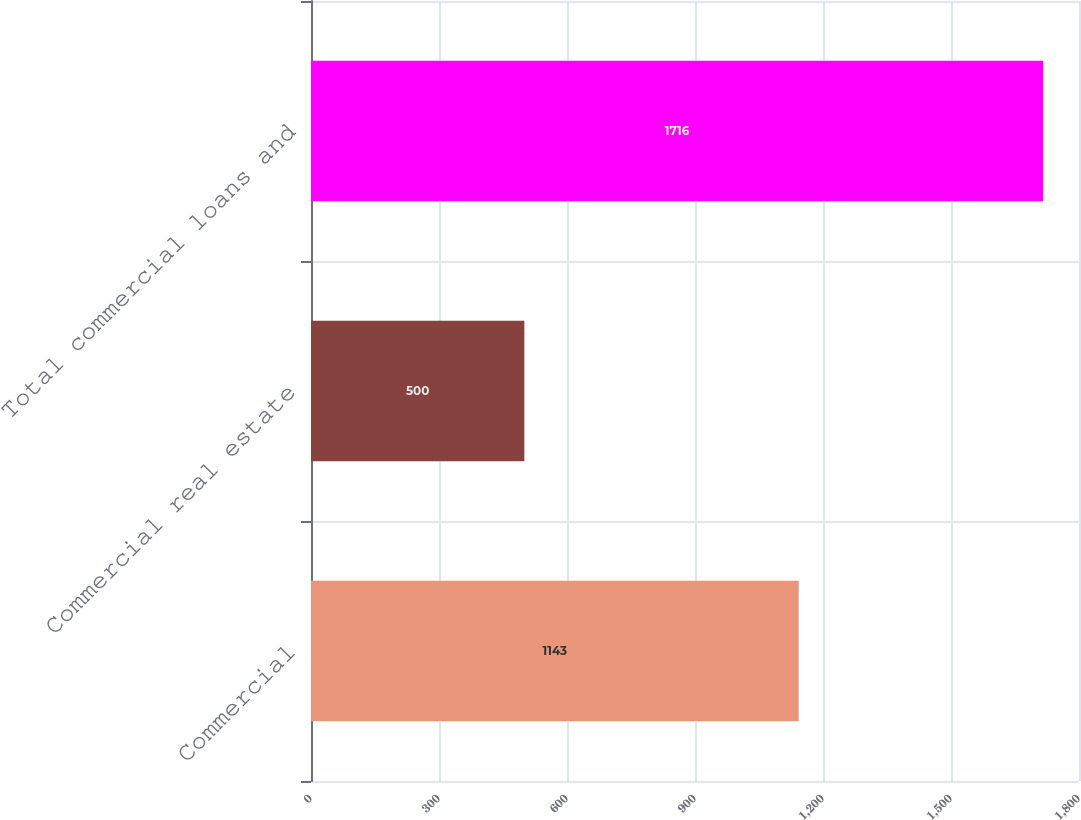Convert chart. <chart><loc_0><loc_0><loc_500><loc_500><bar_chart><fcel>Commercial<fcel>Commercial real estate<fcel>Total commercial loans and<nl><fcel>1143<fcel>500<fcel>1716<nl></chart> 